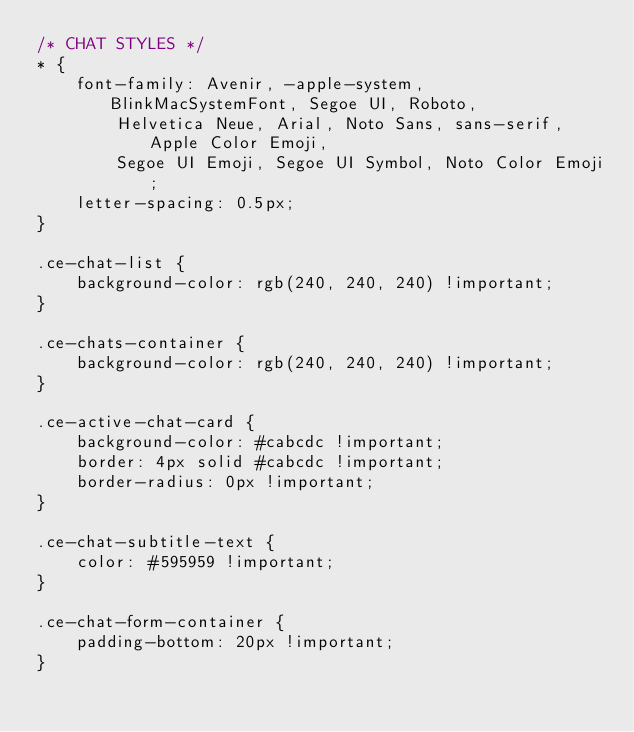Convert code to text. <code><loc_0><loc_0><loc_500><loc_500><_CSS_>/* CHAT STYLES */
* {
    font-family: Avenir, -apple-system, BlinkMacSystemFont, Segoe UI, Roboto,
        Helvetica Neue, Arial, Noto Sans, sans-serif, Apple Color Emoji,
        Segoe UI Emoji, Segoe UI Symbol, Noto Color Emoji;
    letter-spacing: 0.5px;
}

.ce-chat-list {
    background-color: rgb(240, 240, 240) !important;
}

.ce-chats-container {
    background-color: rgb(240, 240, 240) !important;
}

.ce-active-chat-card {
    background-color: #cabcdc !important;
    border: 4px solid #cabcdc !important;
    border-radius: 0px !important;
}

.ce-chat-subtitle-text {
    color: #595959 !important;
}

.ce-chat-form-container {
    padding-bottom: 20px !important;
}
</code> 